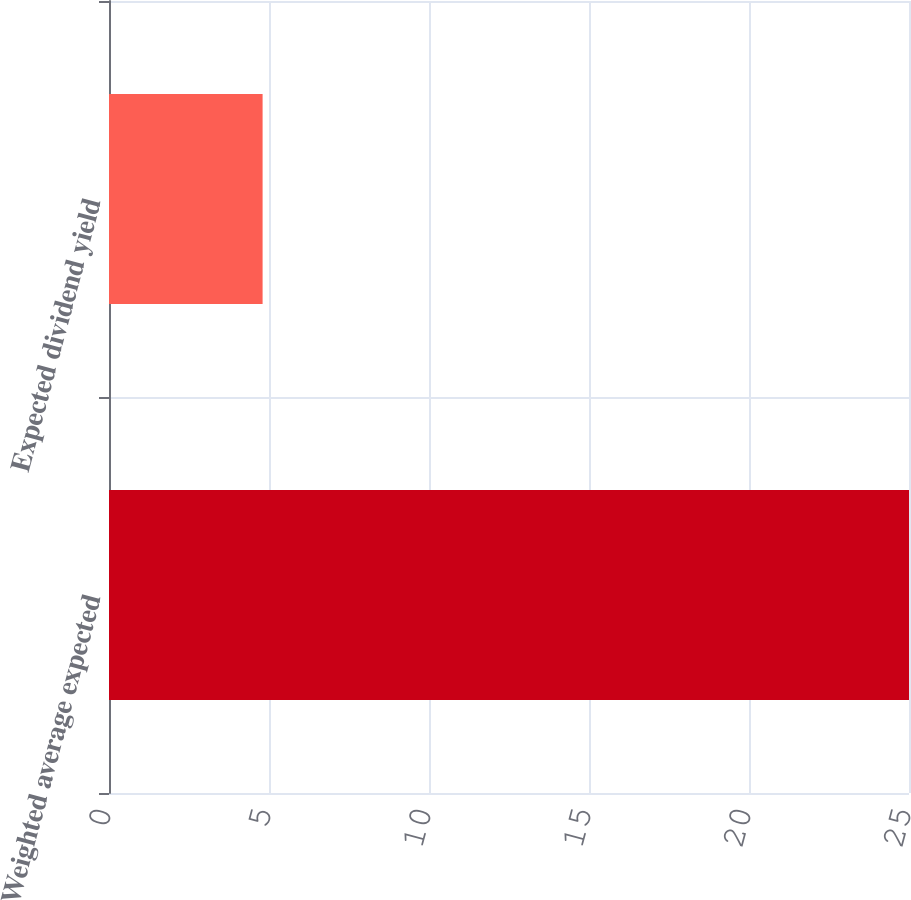Convert chart. <chart><loc_0><loc_0><loc_500><loc_500><bar_chart><fcel>Weighted average expected<fcel>Expected dividend yield<nl><fcel>25<fcel>4.8<nl></chart> 